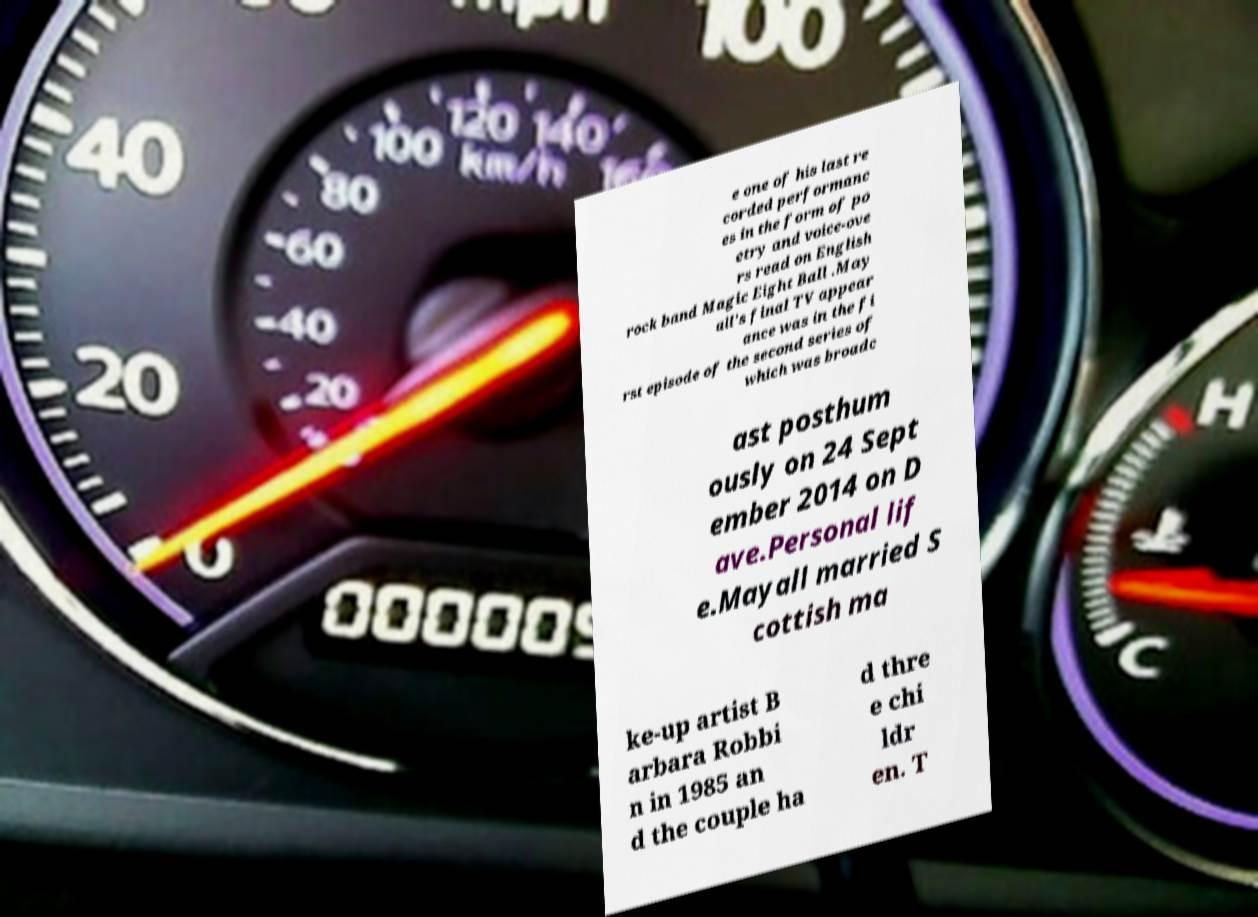Can you accurately transcribe the text from the provided image for me? e one of his last re corded performanc es in the form of po etry and voice-ove rs read on English rock band Magic Eight Ball .May all's final TV appear ance was in the fi rst episode of the second series of which was broadc ast posthum ously on 24 Sept ember 2014 on D ave.Personal lif e.Mayall married S cottish ma ke-up artist B arbara Robbi n in 1985 an d the couple ha d thre e chi ldr en. T 